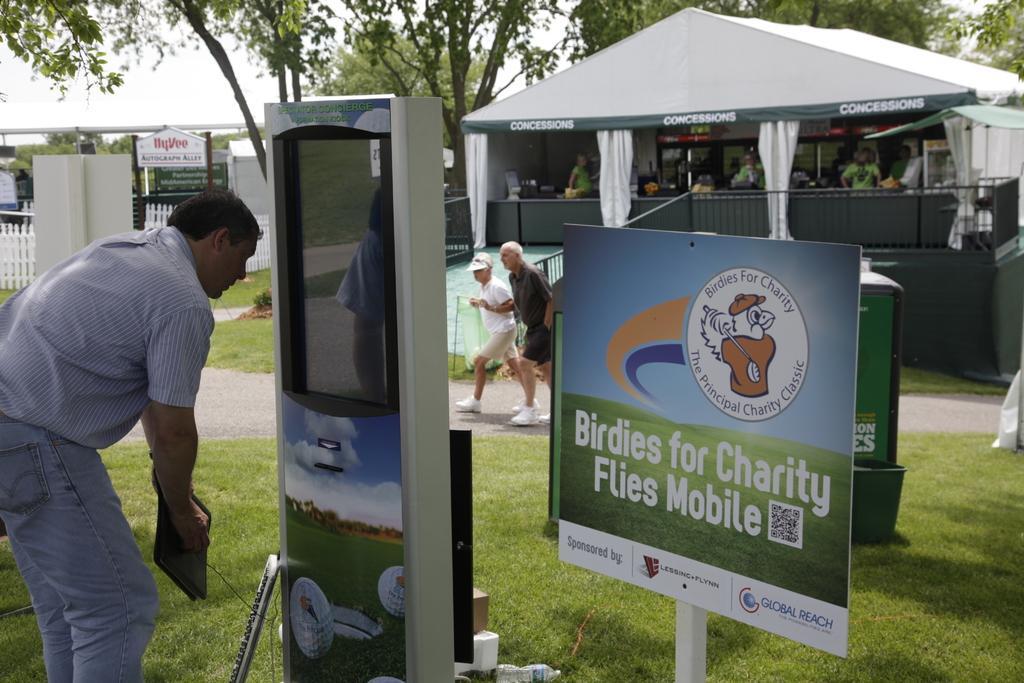Could you give a brief overview of what you see in this image? In this picture we can observe a board fixed to the white color pole. There is a man standing in front of this machine. In the background we can observe two persons walking on this road. There is some grass on the ground. In the background there is a stall and white color curtains. We can observe some trees. There is a sky in the background. 